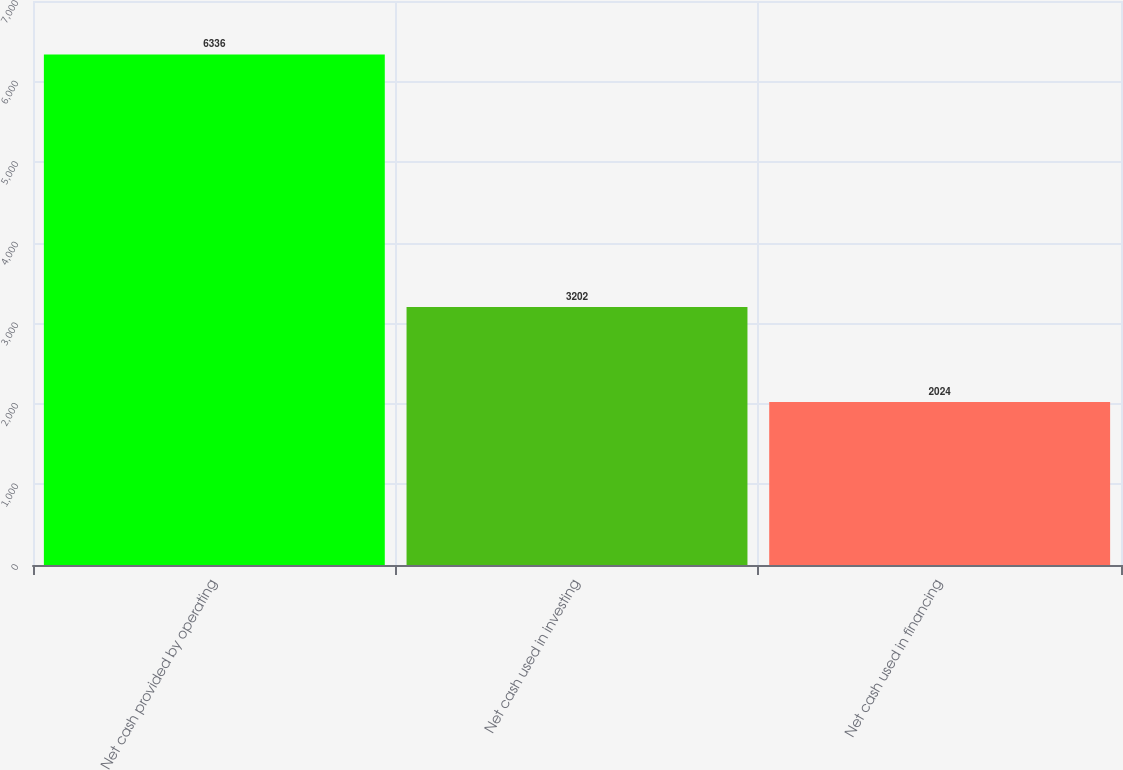<chart> <loc_0><loc_0><loc_500><loc_500><bar_chart><fcel>Net cash provided by operating<fcel>Net cash used in investing<fcel>Net cash used in financing<nl><fcel>6336<fcel>3202<fcel>2024<nl></chart> 